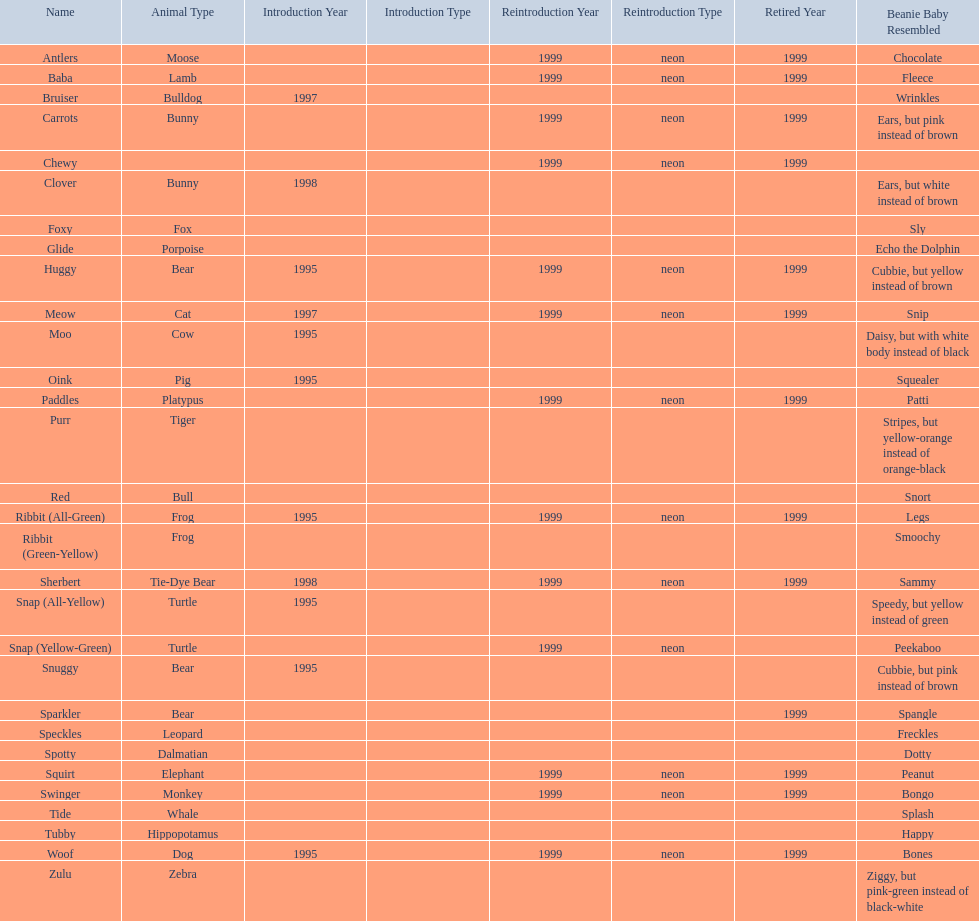What are all the different names of the pillow pals? Antlers, Baba, Bruiser, Carrots, Chewy, Clover, Foxy, Glide, Huggy, Meow, Moo, Oink, Paddles, Purr, Red, Ribbit (All-Green), Ribbit (Green-Yellow), Sherbert, Snap (All-Yellow), Snap (Yellow-Green), Snuggy, Sparkler, Speckles, Spotty, Squirt, Swinger, Tide, Tubby, Woof, Zulu. Which of these are a dalmatian? Spotty. 